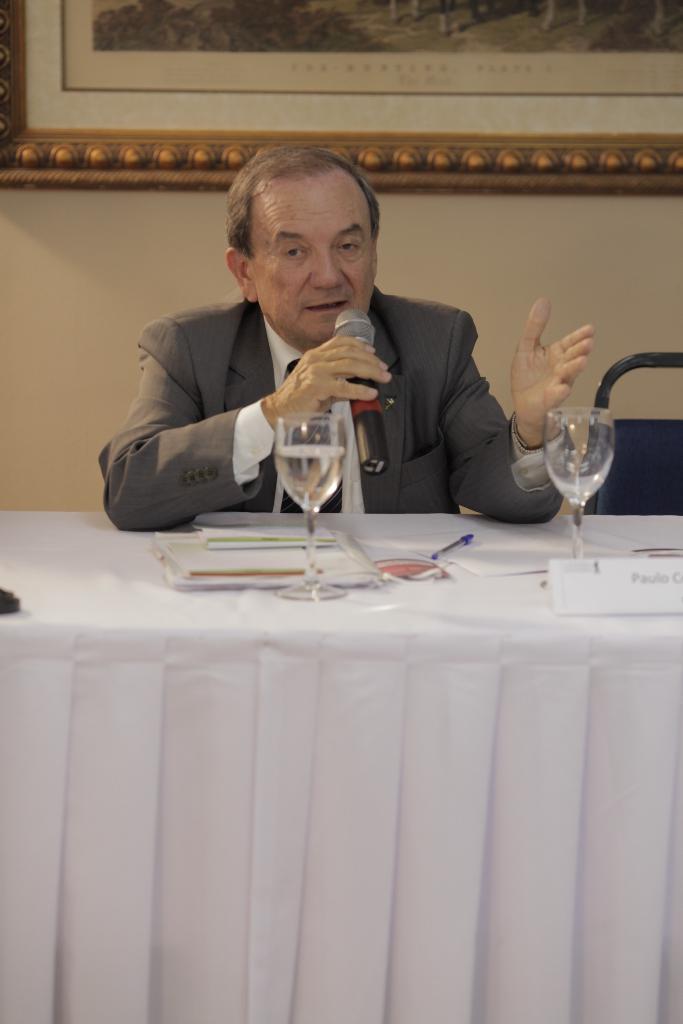Please provide a concise description of this image. In this image in the center there is a table which is covered with a white colour cloth. On the table there are glasses, there is a name plate, pen and there are papers. Behind the table there is a man sitting and holding a mic and speaking. In the background on the wall there is a frame. 